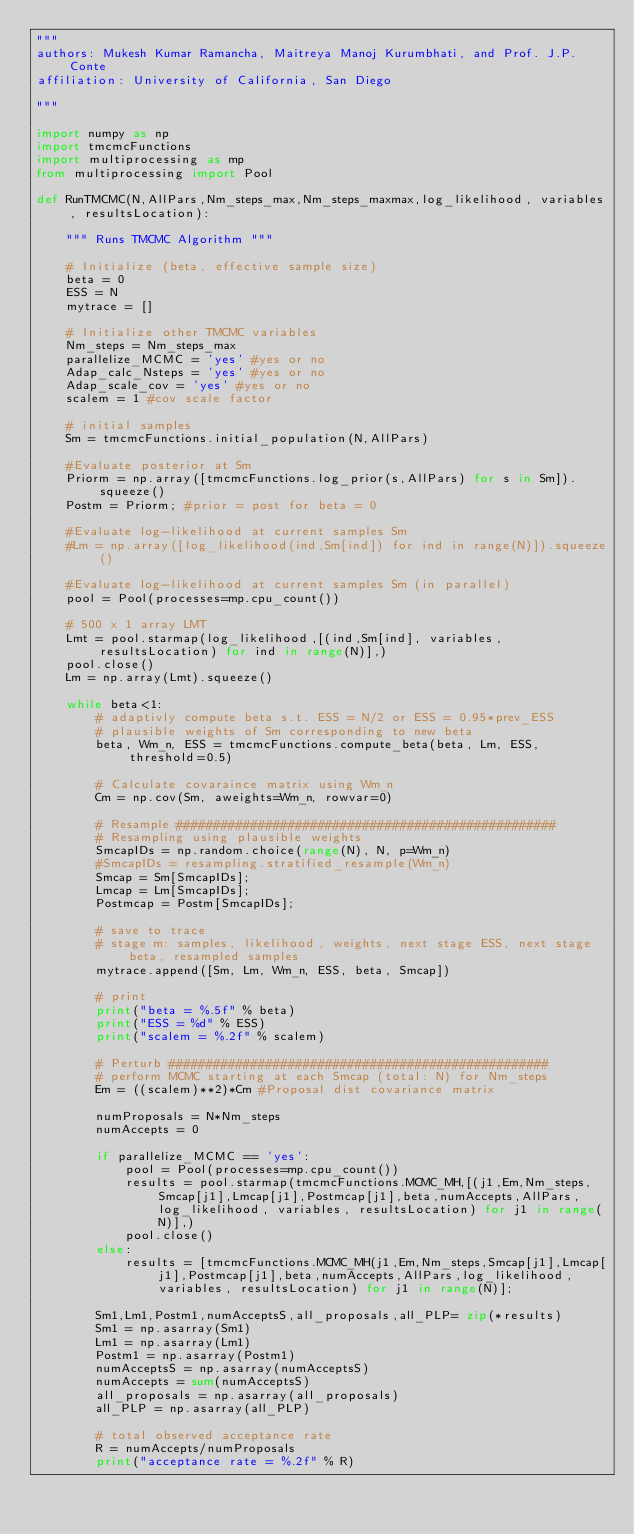<code> <loc_0><loc_0><loc_500><loc_500><_Python_>"""
authors: Mukesh Kumar Ramancha, Maitreya Manoj Kurumbhati, and Prof. J.P. Conte 
affiliation: University of California, San Diego

"""

import numpy as np
import tmcmcFunctions
import multiprocessing as mp
from multiprocessing import Pool

def RunTMCMC(N,AllPars,Nm_steps_max,Nm_steps_maxmax,log_likelihood, variables, resultsLocation):
    
    """ Runs TMCMC Algorithm """
    
    # Initialize (beta, effective sample size)
    beta = 0
    ESS = N
    mytrace = []
    
    # Initialize other TMCMC variables
    Nm_steps = Nm_steps_max
    parallelize_MCMC = 'yes' #yes or no
    Adap_calc_Nsteps = 'yes' #yes or no
    Adap_scale_cov = 'yes' #yes or no
    scalem = 1 #cov scale factor
    
    # initial samples
    Sm = tmcmcFunctions.initial_population(N,AllPars)
    
    #Evaluate posterior at Sm
    Priorm = np.array([tmcmcFunctions.log_prior(s,AllPars) for s in Sm]).squeeze()
    Postm = Priorm; #prior = post for beta = 0
    
    #Evaluate log-likelihood at current samples Sm
    #Lm = np.array([log_likelihood(ind,Sm[ind]) for ind in range(N)]).squeeze()
    
    #Evaluate log-likelihood at current samples Sm (in parallel)
    pool = Pool(processes=mp.cpu_count())
    
    # 500 x 1 array LMT
    Lmt = pool.starmap(log_likelihood,[(ind,Sm[ind], variables, resultsLocation) for ind in range(N)],)
    pool.close()
    Lm = np.array(Lmt).squeeze()
    
    while beta<1:
        # adaptivly compute beta s.t. ESS = N/2 or ESS = 0.95*prev_ESS
        # plausible weights of Sm corresponding to new beta
        beta, Wm_n, ESS = tmcmcFunctions.compute_beta(beta, Lm, ESS, threshold=0.5)
        
        # Calculate covaraince matrix using Wm_n
        Cm = np.cov(Sm, aweights=Wm_n, rowvar=0)
        
        # Resample ###################################################
        # Resampling using plausible weights
        SmcapIDs = np.random.choice(range(N), N, p=Wm_n)
        #SmcapIDs = resampling.stratified_resample(Wm_n)
        Smcap = Sm[SmcapIDs];
        Lmcap = Lm[SmcapIDs];
        Postmcap = Postm[SmcapIDs];
        
        # save to trace
        # stage m: samples, likelihood, weights, next stage ESS, next stage beta, resampled samples
        mytrace.append([Sm, Lm, Wm_n, ESS, beta, Smcap])
        
        # print
        print("beta = %.5f" % beta)
        print("ESS = %d" % ESS)
        print("scalem = %.2f" % scalem)
        
        # Perturb ###################################################
        # perform MCMC starting at each Smcap (total: N) for Nm_steps
        Em = ((scalem)**2)*Cm #Proposal dist covariance matrix
        
        numProposals = N*Nm_steps
        numAccepts = 0
        
        if parallelize_MCMC == 'yes':
            pool = Pool(processes=mp.cpu_count())
            results = pool.starmap(tmcmcFunctions.MCMC_MH,[(j1,Em,Nm_steps,Smcap[j1],Lmcap[j1],Postmcap[j1],beta,numAccepts,AllPars,log_likelihood, variables, resultsLocation) for j1 in range(N)],)
            pool.close()
        else:
            results = [tmcmcFunctions.MCMC_MH(j1,Em,Nm_steps,Smcap[j1],Lmcap[j1],Postmcap[j1],beta,numAccepts,AllPars,log_likelihood, variables, resultsLocation) for j1 in range(N)];
        
        Sm1,Lm1,Postm1,numAcceptsS,all_proposals,all_PLP= zip(*results)
        Sm1 = np.asarray(Sm1)
        Lm1 = np.asarray(Lm1)
        Postm1 = np.asarray(Postm1)
        numAcceptsS = np.asarray(numAcceptsS)
        numAccepts = sum(numAcceptsS)
        all_proposals = np.asarray(all_proposals)
        all_PLP = np.asarray(all_PLP)
        
        # total observed acceptance rate
        R = numAccepts/numProposals
        print("acceptance rate = %.2f" % R)
        </code> 